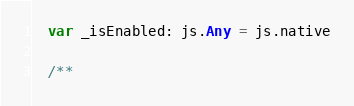Convert code to text. <code><loc_0><loc_0><loc_500><loc_500><_Scala_>  var _isEnabled: js.Any = js.native
  
  /**</code> 